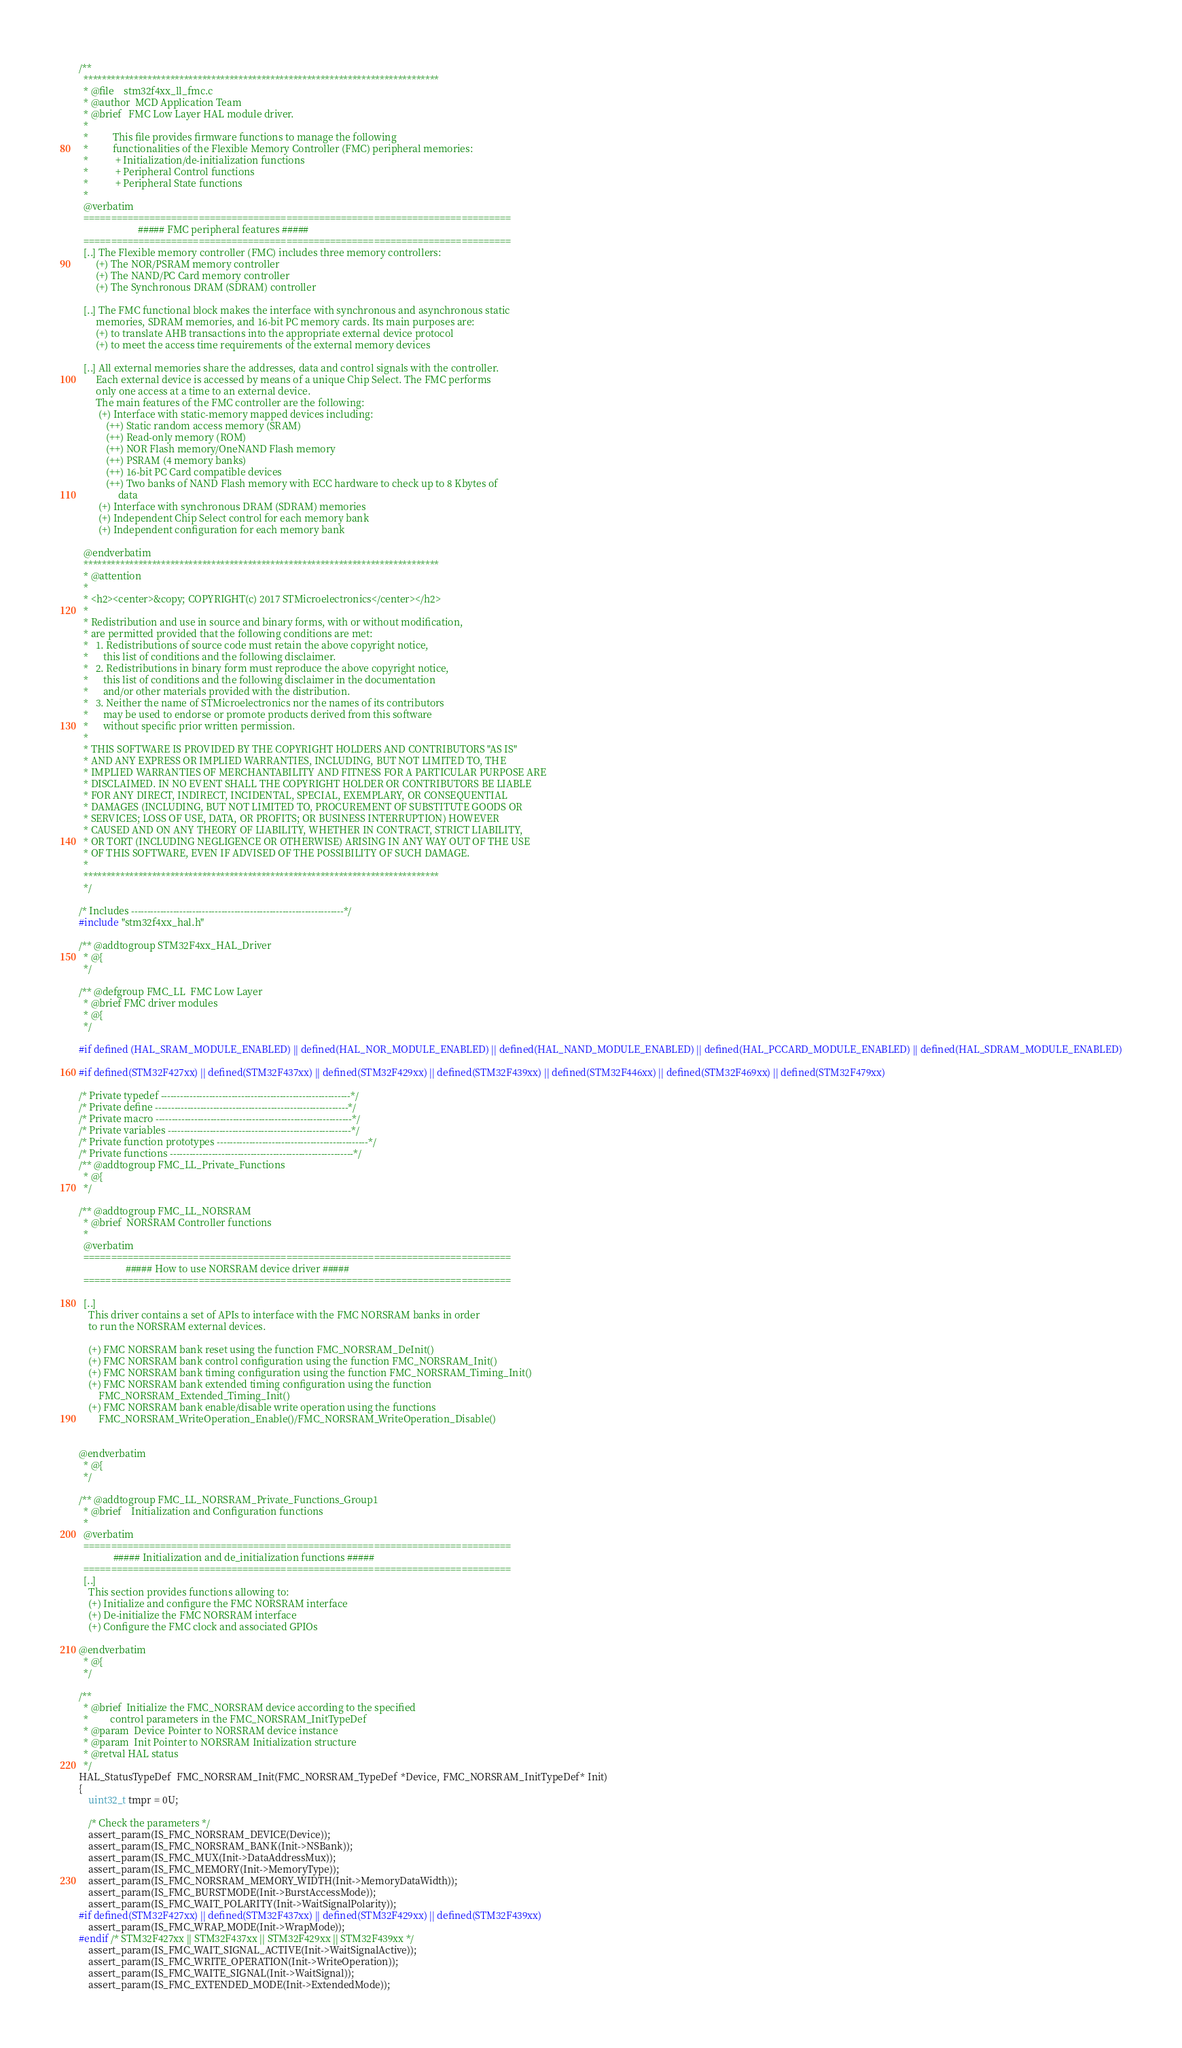<code> <loc_0><loc_0><loc_500><loc_500><_C_>/**
  ******************************************************************************
  * @file    stm32f4xx_ll_fmc.c
  * @author  MCD Application Team
  * @brief   FMC Low Layer HAL module driver.
  *
  *          This file provides firmware functions to manage the following
  *          functionalities of the Flexible Memory Controller (FMC) peripheral memories:
  *           + Initialization/de-initialization functions
  *           + Peripheral Control functions
  *           + Peripheral State functions
  *
  @verbatim
  ==============================================================================
                        ##### FMC peripheral features #####
  ==============================================================================
  [..] The Flexible memory controller (FMC) includes three memory controllers:
       (+) The NOR/PSRAM memory controller
       (+) The NAND/PC Card memory controller
       (+) The Synchronous DRAM (SDRAM) controller

  [..] The FMC functional block makes the interface with synchronous and asynchronous static
       memories, SDRAM memories, and 16-bit PC memory cards. Its main purposes are:
       (+) to translate AHB transactions into the appropriate external device protocol
       (+) to meet the access time requirements of the external memory devices

  [..] All external memories share the addresses, data and control signals with the controller.
       Each external device is accessed by means of a unique Chip Select. The FMC performs
       only one access at a time to an external device.
       The main features of the FMC controller are the following:
        (+) Interface with static-memory mapped devices including:
           (++) Static random access memory (SRAM)
           (++) Read-only memory (ROM)
           (++) NOR Flash memory/OneNAND Flash memory
           (++) PSRAM (4 memory banks)
           (++) 16-bit PC Card compatible devices
           (++) Two banks of NAND Flash memory with ECC hardware to check up to 8 Kbytes of
                data
        (+) Interface with synchronous DRAM (SDRAM) memories
        (+) Independent Chip Select control for each memory bank
        (+) Independent configuration for each memory bank

  @endverbatim
  ******************************************************************************
  * @attention
  *
  * <h2><center>&copy; COPYRIGHT(c) 2017 STMicroelectronics</center></h2>
  *
  * Redistribution and use in source and binary forms, with or without modification,
  * are permitted provided that the following conditions are met:
  *   1. Redistributions of source code must retain the above copyright notice,
  *      this list of conditions and the following disclaimer.
  *   2. Redistributions in binary form must reproduce the above copyright notice,
  *      this list of conditions and the following disclaimer in the documentation
  *      and/or other materials provided with the distribution.
  *   3. Neither the name of STMicroelectronics nor the names of its contributors
  *      may be used to endorse or promote products derived from this software
  *      without specific prior written permission.
  *
  * THIS SOFTWARE IS PROVIDED BY THE COPYRIGHT HOLDERS AND CONTRIBUTORS "AS IS"
  * AND ANY EXPRESS OR IMPLIED WARRANTIES, INCLUDING, BUT NOT LIMITED TO, THE
  * IMPLIED WARRANTIES OF MERCHANTABILITY AND FITNESS FOR A PARTICULAR PURPOSE ARE
  * DISCLAIMED. IN NO EVENT SHALL THE COPYRIGHT HOLDER OR CONTRIBUTORS BE LIABLE
  * FOR ANY DIRECT, INDIRECT, INCIDENTAL, SPECIAL, EXEMPLARY, OR CONSEQUENTIAL
  * DAMAGES (INCLUDING, BUT NOT LIMITED TO, PROCUREMENT OF SUBSTITUTE GOODS OR
  * SERVICES; LOSS OF USE, DATA, OR PROFITS; OR BUSINESS INTERRUPTION) HOWEVER
  * CAUSED AND ON ANY THEORY OF LIABILITY, WHETHER IN CONTRACT, STRICT LIABILITY,
  * OR TORT (INCLUDING NEGLIGENCE OR OTHERWISE) ARISING IN ANY WAY OUT OF THE USE
  * OF THIS SOFTWARE, EVEN IF ADVISED OF THE POSSIBILITY OF SUCH DAMAGE.
  *
  ******************************************************************************
  */

/* Includes ------------------------------------------------------------------*/
#include "stm32f4xx_hal.h"

/** @addtogroup STM32F4xx_HAL_Driver
  * @{
  */

/** @defgroup FMC_LL  FMC Low Layer
  * @brief FMC driver modules
  * @{
  */

#if defined (HAL_SRAM_MODULE_ENABLED) || defined(HAL_NOR_MODULE_ENABLED) || defined(HAL_NAND_MODULE_ENABLED) || defined(HAL_PCCARD_MODULE_ENABLED) || defined(HAL_SDRAM_MODULE_ENABLED)

#if defined(STM32F427xx) || defined(STM32F437xx) || defined(STM32F429xx) || defined(STM32F439xx) || defined(STM32F446xx) || defined(STM32F469xx) || defined(STM32F479xx)

/* Private typedef -----------------------------------------------------------*/
/* Private define ------------------------------------------------------------*/
/* Private macro -------------------------------------------------------------*/
/* Private variables ---------------------------------------------------------*/
/* Private function prototypes -----------------------------------------------*/
/* Private functions ---------------------------------------------------------*/
/** @addtogroup FMC_LL_Private_Functions
  * @{
  */

/** @addtogroup FMC_LL_NORSRAM
  * @brief  NORSRAM Controller functions
  *
  @verbatim
  ==============================================================================
                   ##### How to use NORSRAM device driver #####
  ==============================================================================

  [..]
    This driver contains a set of APIs to interface with the FMC NORSRAM banks in order
    to run the NORSRAM external devices.

    (+) FMC NORSRAM bank reset using the function FMC_NORSRAM_DeInit()
    (+) FMC NORSRAM bank control configuration using the function FMC_NORSRAM_Init()
    (+) FMC NORSRAM bank timing configuration using the function FMC_NORSRAM_Timing_Init()
    (+) FMC NORSRAM bank extended timing configuration using the function
        FMC_NORSRAM_Extended_Timing_Init()
    (+) FMC NORSRAM bank enable/disable write operation using the functions
        FMC_NORSRAM_WriteOperation_Enable()/FMC_NORSRAM_WriteOperation_Disable()


@endverbatim
  * @{
  */

/** @addtogroup FMC_LL_NORSRAM_Private_Functions_Group1
  * @brief    Initialization and Configuration functions
  *
  @verbatim
  ==============================================================================
              ##### Initialization and de_initialization functions #####
  ==============================================================================
  [..]
    This section provides functions allowing to:
    (+) Initialize and configure the FMC NORSRAM interface
    (+) De-initialize the FMC NORSRAM interface
    (+) Configure the FMC clock and associated GPIOs

@endverbatim
  * @{
  */

/**
  * @brief  Initialize the FMC_NORSRAM device according to the specified
  *         control parameters in the FMC_NORSRAM_InitTypeDef
  * @param  Device Pointer to NORSRAM device instance
  * @param  Init Pointer to NORSRAM Initialization structure
  * @retval HAL status
  */
HAL_StatusTypeDef  FMC_NORSRAM_Init(FMC_NORSRAM_TypeDef *Device, FMC_NORSRAM_InitTypeDef* Init)
{
    uint32_t tmpr = 0U;

    /* Check the parameters */
    assert_param(IS_FMC_NORSRAM_DEVICE(Device));
    assert_param(IS_FMC_NORSRAM_BANK(Init->NSBank));
    assert_param(IS_FMC_MUX(Init->DataAddressMux));
    assert_param(IS_FMC_MEMORY(Init->MemoryType));
    assert_param(IS_FMC_NORSRAM_MEMORY_WIDTH(Init->MemoryDataWidth));
    assert_param(IS_FMC_BURSTMODE(Init->BurstAccessMode));
    assert_param(IS_FMC_WAIT_POLARITY(Init->WaitSignalPolarity));
#if defined(STM32F427xx) || defined(STM32F437xx) || defined(STM32F429xx) || defined(STM32F439xx)
    assert_param(IS_FMC_WRAP_MODE(Init->WrapMode));
#endif /* STM32F427xx || STM32F437xx || STM32F429xx || STM32F439xx */
    assert_param(IS_FMC_WAIT_SIGNAL_ACTIVE(Init->WaitSignalActive));
    assert_param(IS_FMC_WRITE_OPERATION(Init->WriteOperation));
    assert_param(IS_FMC_WAITE_SIGNAL(Init->WaitSignal));
    assert_param(IS_FMC_EXTENDED_MODE(Init->ExtendedMode));</code> 